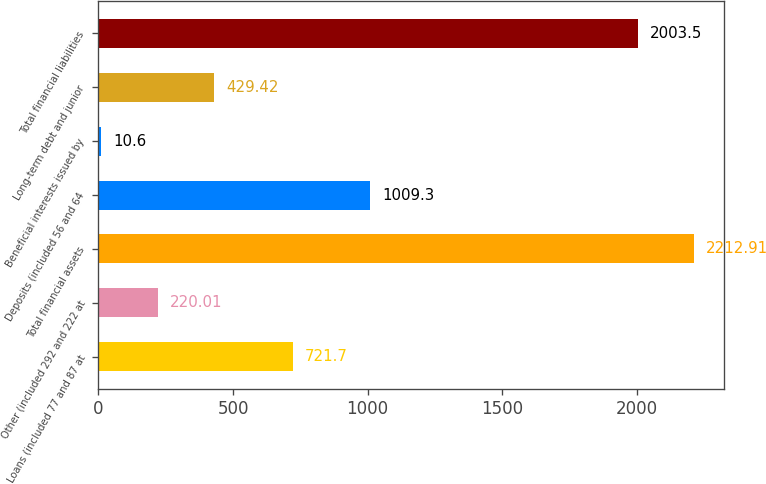Convert chart. <chart><loc_0><loc_0><loc_500><loc_500><bar_chart><fcel>Loans (included 77 and 87 at<fcel>Other (included 292 and 222 at<fcel>Total financial assets<fcel>Deposits (included 56 and 64<fcel>Beneficial interests issued by<fcel>Long-term debt and junior<fcel>Total financial liabilities<nl><fcel>721.7<fcel>220.01<fcel>2212.91<fcel>1009.3<fcel>10.6<fcel>429.42<fcel>2003.5<nl></chart> 